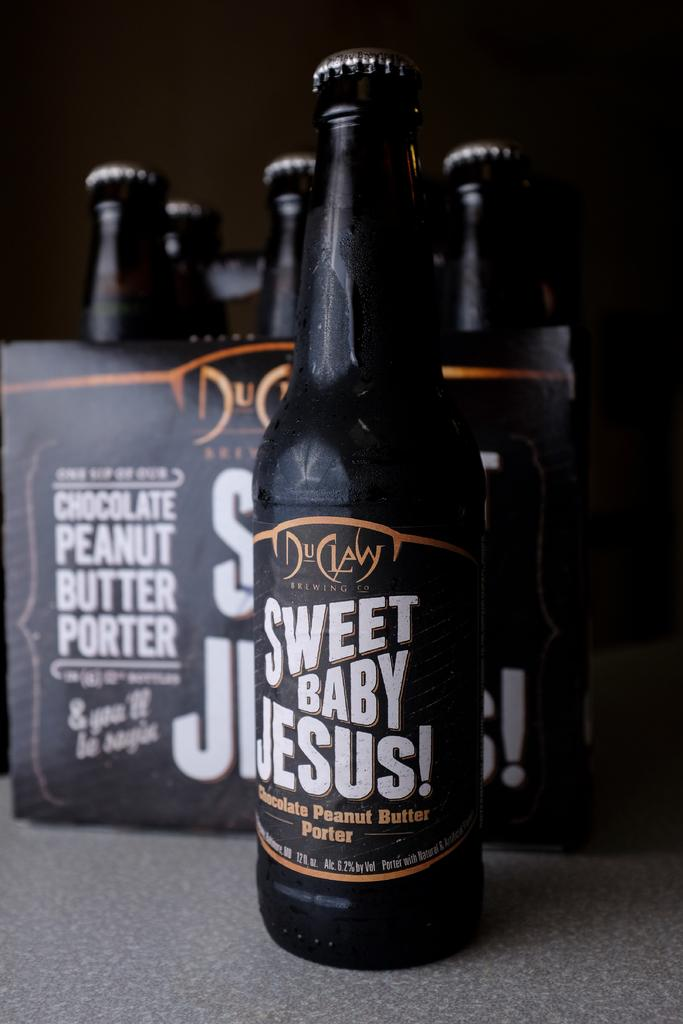<image>
Summarize the visual content of the image. a bottle that says sweet baby jesus on it 